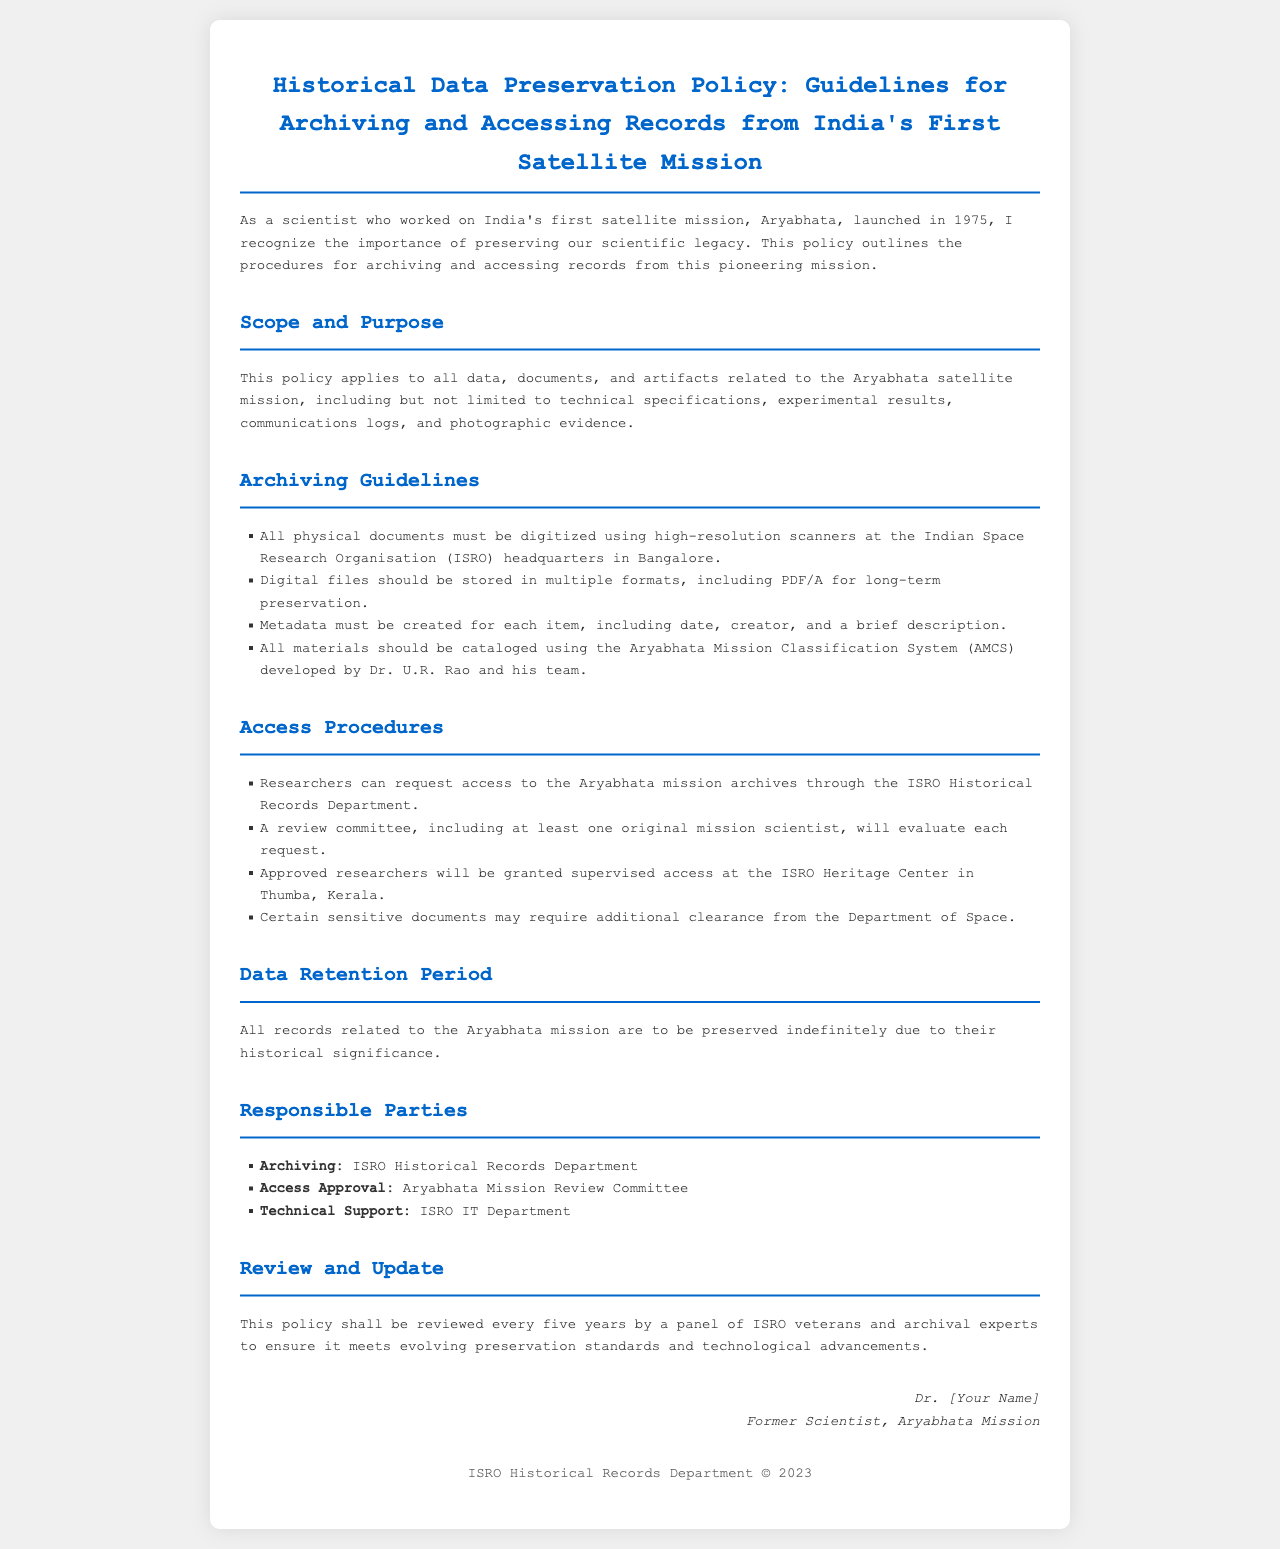what is the title of the document? The title of the document is shown prominently at the top of the rendered output, indicating the focus of the policy.
Answer: Historical Data Preservation Policy: Guidelines for Archiving and Accessing Records from India's First Satellite Mission who is responsible for archiving? The policy document lists the responsible party for archiving as the body responsible for historical records at ISRO.
Answer: ISRO Historical Records Department what is the data retention period for Aryabhata mission records? The document specifies the duration for which the records related to the mission are to be kept.
Answer: Indefinitely who will evaluate access requests? The policy indicates a specific committee that reviews the requests for accessing the archives, comprising original mission scientists.
Answer: Aryabhata Mission Review Committee how often will the policy be reviewed? The document states the frequency at which the policy will be reviewed to ensure compliance with evolving standards.
Answer: Every five years what type of sensitive documents may require additional clearance? The document hints at specific types of records that need extra consent for access due to their sensitive nature.
Answer: Certain sensitive documents what is the purpose of creating metadata for each item? The document outlines the necessity of metadata in relation to the archiving process to describe archived items properly.
Answer: To create a brief description, including date and creator 